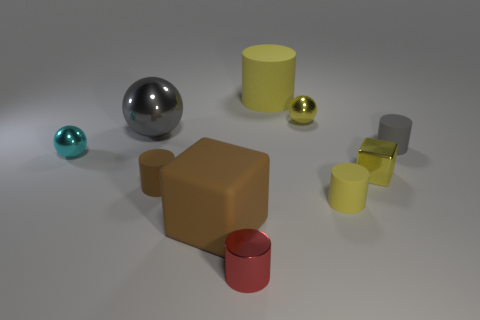How many other objects are the same material as the yellow cube?
Keep it short and to the point. 4. Is the material of the gray object that is to the right of the large gray ball the same as the gray sphere?
Make the answer very short. No. What is the shape of the cyan thing?
Keep it short and to the point. Sphere. Are there more small brown objects that are behind the small gray object than large things?
Make the answer very short. No. Is there any other thing that is the same shape as the gray metal object?
Offer a very short reply. Yes. There is a big object that is the same shape as the small brown object; what is its color?
Offer a very short reply. Yellow. There is a large object in front of the gray cylinder; what shape is it?
Provide a short and direct response. Cube. Are there any cubes right of the large yellow cylinder?
Your response must be concise. Yes. Is there any other thing that has the same size as the brown cylinder?
Keep it short and to the point. Yes. There is a large ball that is made of the same material as the cyan object; what color is it?
Your answer should be compact. Gray. 